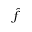<formula> <loc_0><loc_0><loc_500><loc_500>\widehat { f }</formula> 